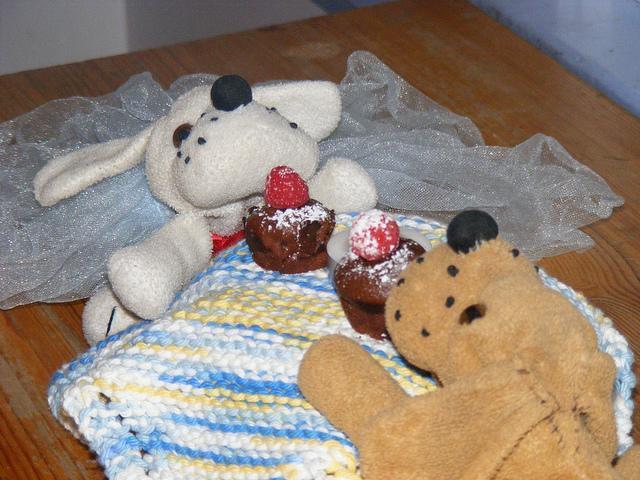How many cakes can you see?
Give a very brief answer. 2. How many teddy bears are in the picture?
Give a very brief answer. 2. 